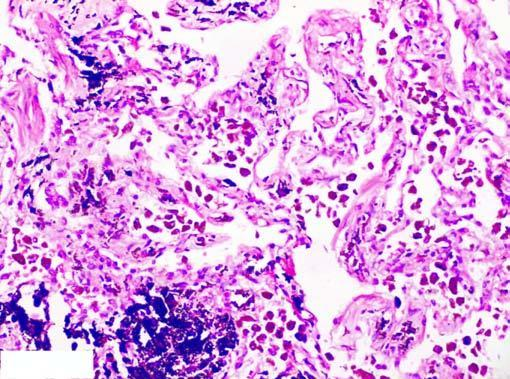s the cytoplasm presence of abundant coarse black carbon pigment in the septal walls and around the bronchiole?
Answer the question using a single word or phrase. No 